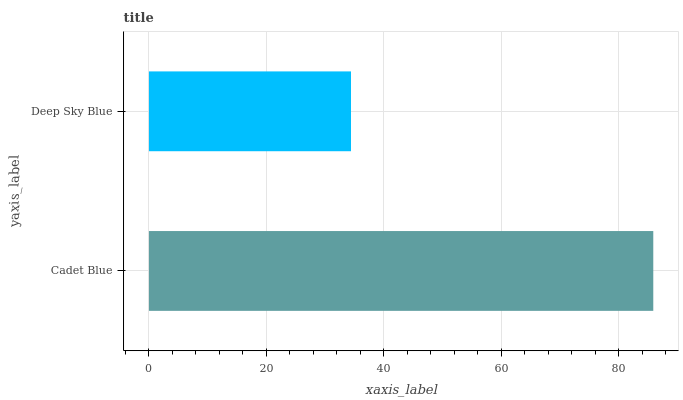Is Deep Sky Blue the minimum?
Answer yes or no. Yes. Is Cadet Blue the maximum?
Answer yes or no. Yes. Is Deep Sky Blue the maximum?
Answer yes or no. No. Is Cadet Blue greater than Deep Sky Blue?
Answer yes or no. Yes. Is Deep Sky Blue less than Cadet Blue?
Answer yes or no. Yes. Is Deep Sky Blue greater than Cadet Blue?
Answer yes or no. No. Is Cadet Blue less than Deep Sky Blue?
Answer yes or no. No. Is Cadet Blue the high median?
Answer yes or no. Yes. Is Deep Sky Blue the low median?
Answer yes or no. Yes. Is Deep Sky Blue the high median?
Answer yes or no. No. Is Cadet Blue the low median?
Answer yes or no. No. 